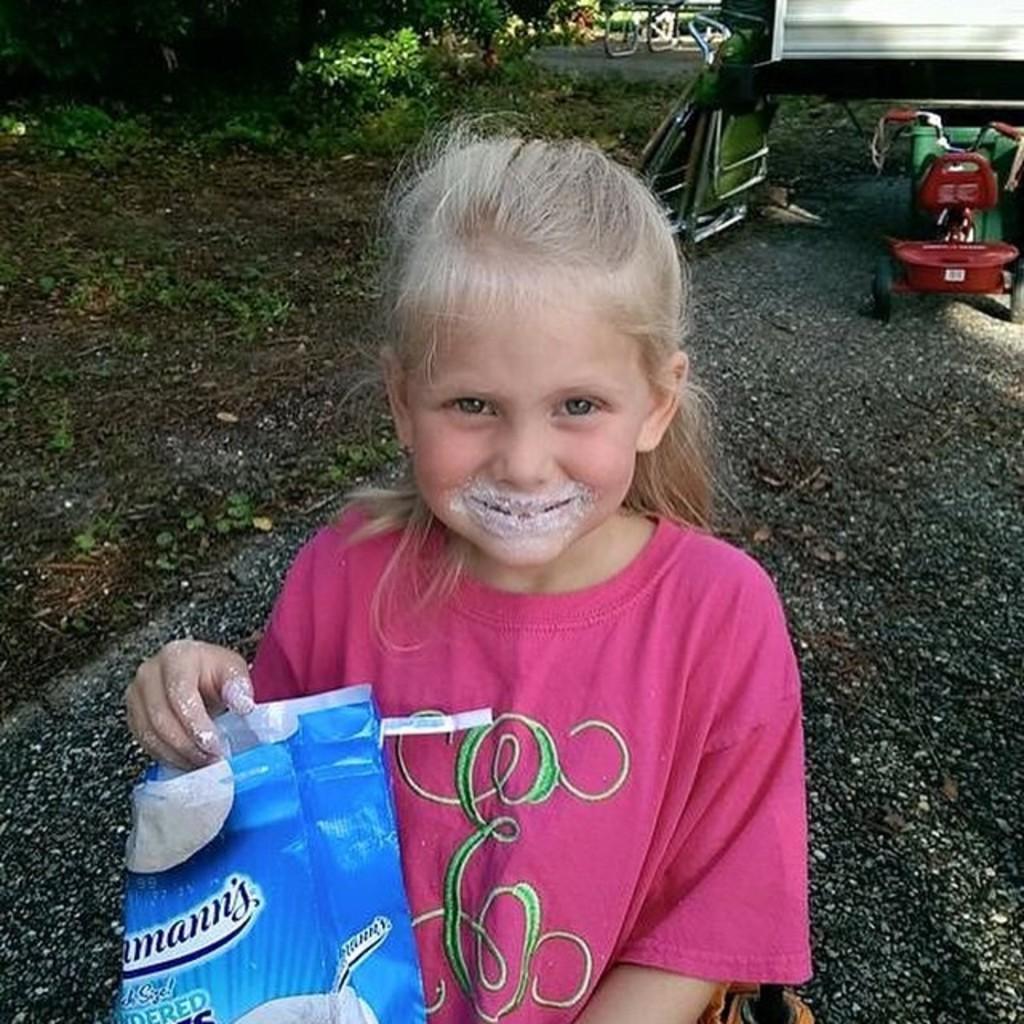Describe this image in one or two sentences. In this image we can see a girl holding a packet with her hand. In the right side of the image we can see a tricycle, a container, a vehicle and some folding chairs placed on the ground. At the top of the image we can see a group of trees and some plants. 